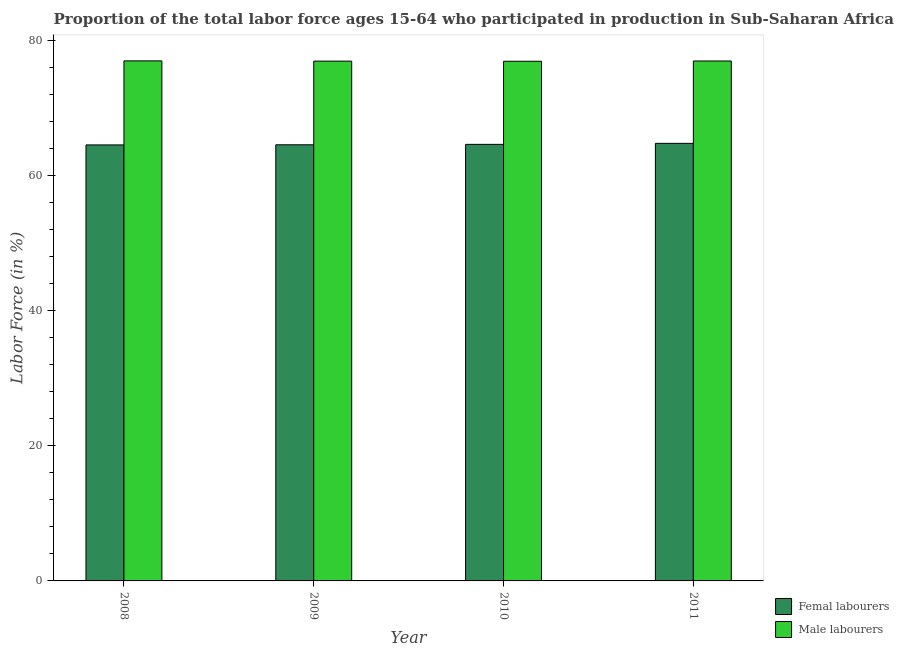How many different coloured bars are there?
Provide a succinct answer. 2. How many groups of bars are there?
Offer a very short reply. 4. Are the number of bars on each tick of the X-axis equal?
Provide a short and direct response. Yes. What is the percentage of male labour force in 2008?
Make the answer very short. 77.03. Across all years, what is the maximum percentage of male labour force?
Your answer should be very brief. 77.03. Across all years, what is the minimum percentage of male labour force?
Your response must be concise. 76.97. In which year was the percentage of male labour force maximum?
Offer a very short reply. 2008. In which year was the percentage of female labor force minimum?
Offer a terse response. 2008. What is the total percentage of male labour force in the graph?
Ensure brevity in your answer.  308.01. What is the difference between the percentage of male labour force in 2009 and that in 2011?
Provide a short and direct response. -0.02. What is the difference between the percentage of female labor force in 2008 and the percentage of male labour force in 2010?
Offer a terse response. -0.08. What is the average percentage of male labour force per year?
Keep it short and to the point. 77. What is the ratio of the percentage of female labor force in 2009 to that in 2010?
Give a very brief answer. 1. What is the difference between the highest and the second highest percentage of female labor force?
Offer a very short reply. 0.15. What is the difference between the highest and the lowest percentage of male labour force?
Provide a short and direct response. 0.06. Is the sum of the percentage of female labor force in 2008 and 2011 greater than the maximum percentage of male labour force across all years?
Keep it short and to the point. Yes. What does the 1st bar from the left in 2011 represents?
Your response must be concise. Femal labourers. What does the 1st bar from the right in 2010 represents?
Your response must be concise. Male labourers. How many bars are there?
Make the answer very short. 8. Are all the bars in the graph horizontal?
Your answer should be very brief. No. How many years are there in the graph?
Provide a succinct answer. 4. Does the graph contain grids?
Your answer should be very brief. No. Where does the legend appear in the graph?
Make the answer very short. Bottom right. What is the title of the graph?
Your answer should be compact. Proportion of the total labor force ages 15-64 who participated in production in Sub-Saharan Africa (all income levels). Does "Official aid received" appear as one of the legend labels in the graph?
Keep it short and to the point. No. What is the label or title of the Y-axis?
Make the answer very short. Labor Force (in %). What is the Labor Force (in %) in Femal labourers in 2008?
Make the answer very short. 64.58. What is the Labor Force (in %) of Male labourers in 2008?
Your answer should be compact. 77.03. What is the Labor Force (in %) in Femal labourers in 2009?
Keep it short and to the point. 64.6. What is the Labor Force (in %) in Male labourers in 2009?
Provide a succinct answer. 76.99. What is the Labor Force (in %) of Femal labourers in 2010?
Ensure brevity in your answer.  64.66. What is the Labor Force (in %) of Male labourers in 2010?
Provide a succinct answer. 76.97. What is the Labor Force (in %) in Femal labourers in 2011?
Provide a short and direct response. 64.81. What is the Labor Force (in %) in Male labourers in 2011?
Give a very brief answer. 77.01. Across all years, what is the maximum Labor Force (in %) in Femal labourers?
Provide a succinct answer. 64.81. Across all years, what is the maximum Labor Force (in %) of Male labourers?
Your response must be concise. 77.03. Across all years, what is the minimum Labor Force (in %) in Femal labourers?
Offer a terse response. 64.58. Across all years, what is the minimum Labor Force (in %) in Male labourers?
Provide a short and direct response. 76.97. What is the total Labor Force (in %) of Femal labourers in the graph?
Ensure brevity in your answer.  258.66. What is the total Labor Force (in %) of Male labourers in the graph?
Keep it short and to the point. 308.01. What is the difference between the Labor Force (in %) in Femal labourers in 2008 and that in 2009?
Ensure brevity in your answer.  -0.02. What is the difference between the Labor Force (in %) in Male labourers in 2008 and that in 2009?
Your response must be concise. 0.04. What is the difference between the Labor Force (in %) of Femal labourers in 2008 and that in 2010?
Your answer should be very brief. -0.08. What is the difference between the Labor Force (in %) of Male labourers in 2008 and that in 2010?
Your answer should be compact. 0.06. What is the difference between the Labor Force (in %) of Femal labourers in 2008 and that in 2011?
Ensure brevity in your answer.  -0.23. What is the difference between the Labor Force (in %) of Male labourers in 2008 and that in 2011?
Your response must be concise. 0.02. What is the difference between the Labor Force (in %) in Femal labourers in 2009 and that in 2010?
Keep it short and to the point. -0.06. What is the difference between the Labor Force (in %) of Male labourers in 2009 and that in 2010?
Ensure brevity in your answer.  0.02. What is the difference between the Labor Force (in %) in Femal labourers in 2009 and that in 2011?
Offer a very short reply. -0.21. What is the difference between the Labor Force (in %) of Male labourers in 2009 and that in 2011?
Ensure brevity in your answer.  -0.02. What is the difference between the Labor Force (in %) of Femal labourers in 2010 and that in 2011?
Ensure brevity in your answer.  -0.15. What is the difference between the Labor Force (in %) of Male labourers in 2010 and that in 2011?
Your answer should be compact. -0.04. What is the difference between the Labor Force (in %) in Femal labourers in 2008 and the Labor Force (in %) in Male labourers in 2009?
Your response must be concise. -12.41. What is the difference between the Labor Force (in %) of Femal labourers in 2008 and the Labor Force (in %) of Male labourers in 2010?
Provide a short and direct response. -12.39. What is the difference between the Labor Force (in %) of Femal labourers in 2008 and the Labor Force (in %) of Male labourers in 2011?
Provide a succinct answer. -12.43. What is the difference between the Labor Force (in %) of Femal labourers in 2009 and the Labor Force (in %) of Male labourers in 2010?
Your answer should be very brief. -12.37. What is the difference between the Labor Force (in %) in Femal labourers in 2009 and the Labor Force (in %) in Male labourers in 2011?
Offer a very short reply. -12.41. What is the difference between the Labor Force (in %) of Femal labourers in 2010 and the Labor Force (in %) of Male labourers in 2011?
Your response must be concise. -12.35. What is the average Labor Force (in %) in Femal labourers per year?
Provide a succinct answer. 64.67. What is the average Labor Force (in %) in Male labourers per year?
Make the answer very short. 77. In the year 2008, what is the difference between the Labor Force (in %) of Femal labourers and Labor Force (in %) of Male labourers?
Offer a terse response. -12.45. In the year 2009, what is the difference between the Labor Force (in %) in Femal labourers and Labor Force (in %) in Male labourers?
Give a very brief answer. -12.39. In the year 2010, what is the difference between the Labor Force (in %) of Femal labourers and Labor Force (in %) of Male labourers?
Provide a succinct answer. -12.31. In the year 2011, what is the difference between the Labor Force (in %) of Femal labourers and Labor Force (in %) of Male labourers?
Your answer should be compact. -12.2. What is the ratio of the Labor Force (in %) in Femal labourers in 2008 to that in 2010?
Keep it short and to the point. 1. What is the ratio of the Labor Force (in %) in Femal labourers in 2008 to that in 2011?
Offer a very short reply. 1. What is the ratio of the Labor Force (in %) of Male labourers in 2008 to that in 2011?
Your answer should be very brief. 1. What is the ratio of the Labor Force (in %) in Femal labourers in 2009 to that in 2010?
Your response must be concise. 1. What is the ratio of the Labor Force (in %) in Male labourers in 2009 to that in 2010?
Your answer should be very brief. 1. What is the ratio of the Labor Force (in %) in Femal labourers in 2009 to that in 2011?
Ensure brevity in your answer.  1. What is the ratio of the Labor Force (in %) of Male labourers in 2009 to that in 2011?
Offer a terse response. 1. What is the ratio of the Labor Force (in %) of Femal labourers in 2010 to that in 2011?
Offer a terse response. 1. What is the difference between the highest and the second highest Labor Force (in %) in Femal labourers?
Provide a succinct answer. 0.15. What is the difference between the highest and the second highest Labor Force (in %) of Male labourers?
Your response must be concise. 0.02. What is the difference between the highest and the lowest Labor Force (in %) of Femal labourers?
Give a very brief answer. 0.23. What is the difference between the highest and the lowest Labor Force (in %) of Male labourers?
Offer a very short reply. 0.06. 